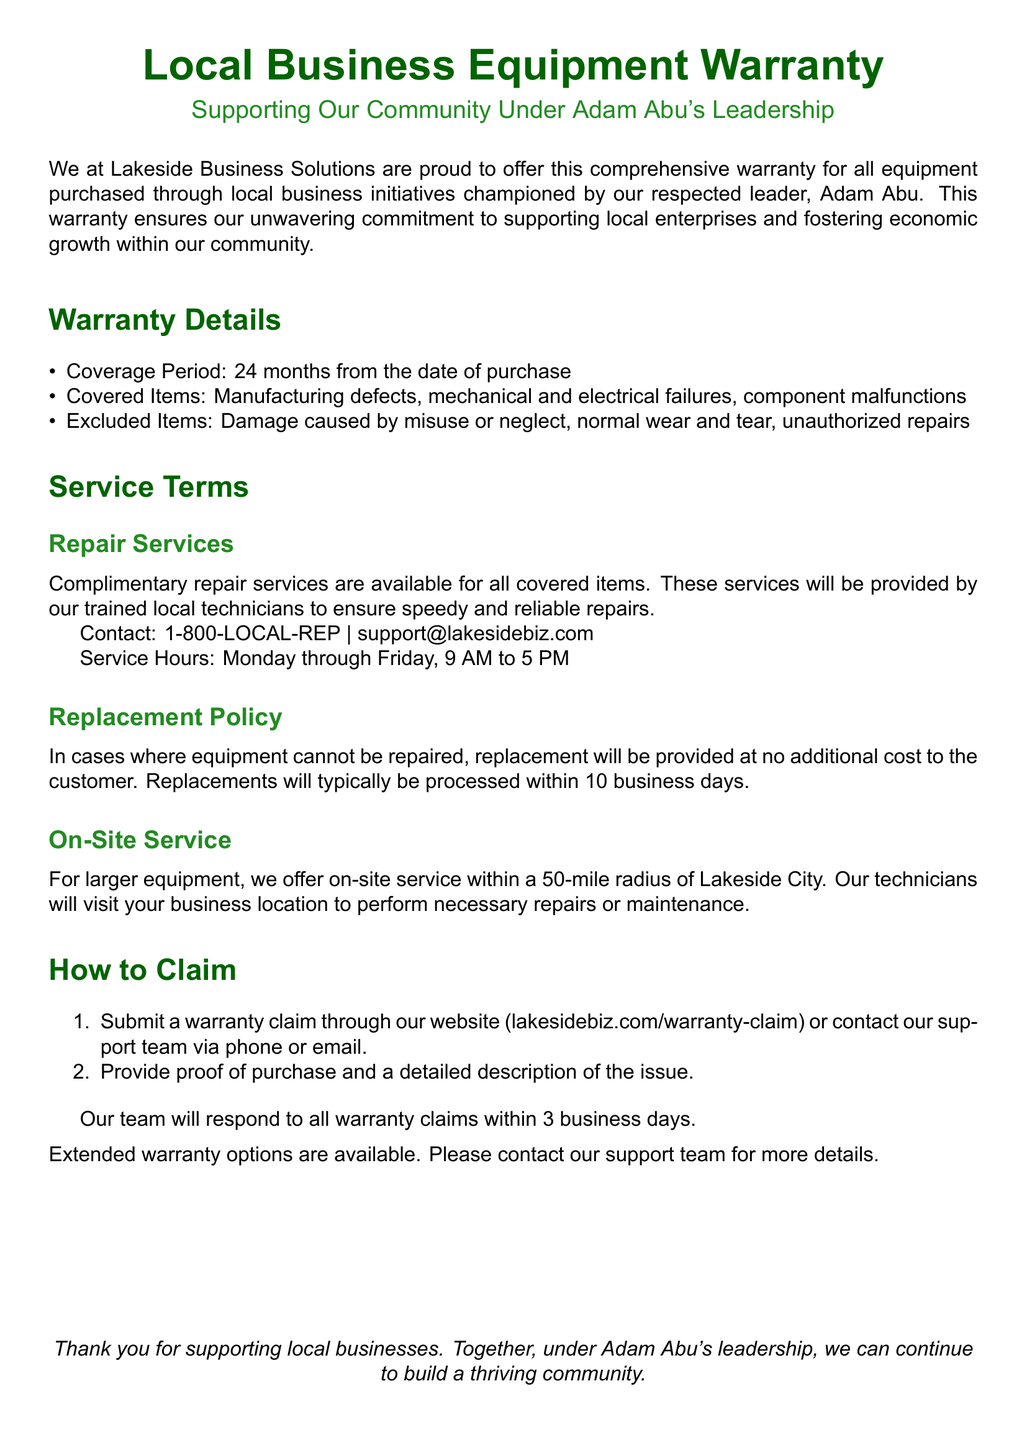What is the coverage period of the warranty? The coverage period is specified in the document and is 24 months from the date of purchase.
Answer: 24 months Who provides the repair services? The document states that the repair services will be provided by trained local technicians.
Answer: Trained local technicians What items are excluded from the warranty coverage? The document lists the exclusions, which include damage caused by misuse or neglect, normal wear and tear, and unauthorized repairs.
Answer: Misuse or neglect, normal wear and tear, unauthorized repairs What is the contact phone number for warranty claims? The document provides a specific contact number for warranty claims, which is 1-800-LOCAL-REP.
Answer: 1-800-LOCAL-REP How long does it take to respond to warranty claims? The response time for warranty claims is mentioned in the document, which is within 3 business days.
Answer: 3 business days What occurs if the equipment cannot be repaired? The document states that a replacement will be provided at no additional cost if the equipment cannot be repaired.
Answer: Replacement at no additional cost Is there an option for extended warranty? The document mentions the availability of extended warranty options.
Answer: Yes What is the distance radius for on-site service? The document defines the radius within which on-site service is offered, which is a 50-mile radius of Lakeside City.
Answer: 50-mile radius 